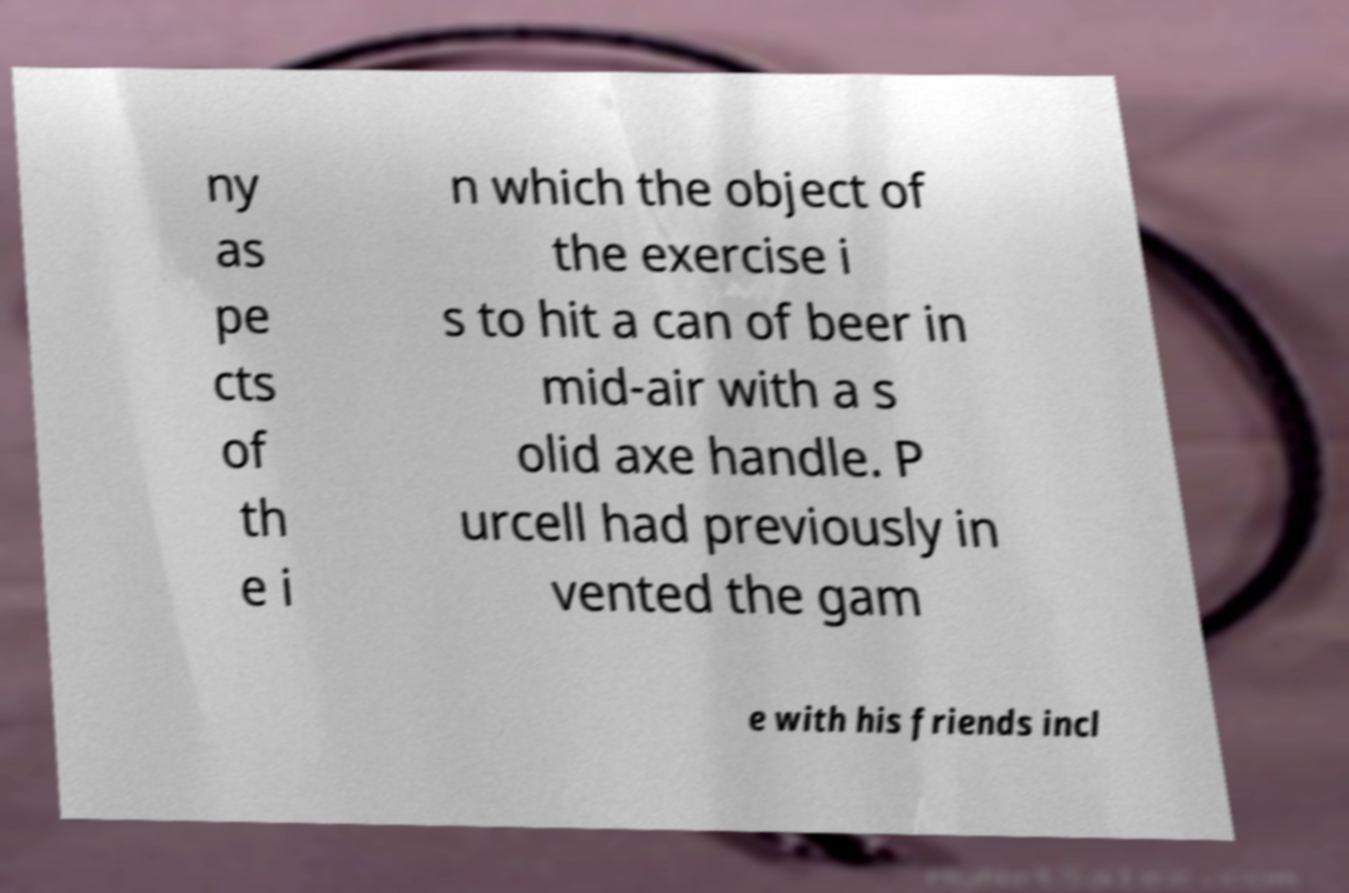What messages or text are displayed in this image? I need them in a readable, typed format. ny as pe cts of th e i n which the object of the exercise i s to hit a can of beer in mid-air with a s olid axe handle. P urcell had previously in vented the gam e with his friends incl 